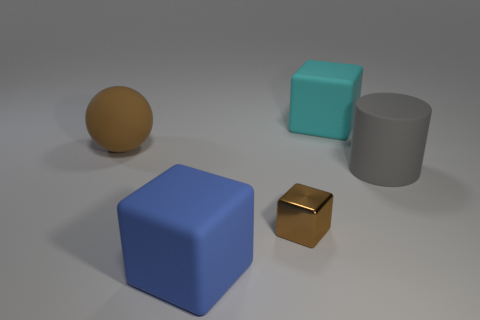Add 3 big gray things. How many objects exist? 8 Subtract all cubes. How many objects are left? 2 Add 3 large spheres. How many large spheres exist? 4 Subtract 0 gray balls. How many objects are left? 5 Subtract all blue metallic objects. Subtract all rubber cylinders. How many objects are left? 4 Add 5 gray rubber cylinders. How many gray rubber cylinders are left? 6 